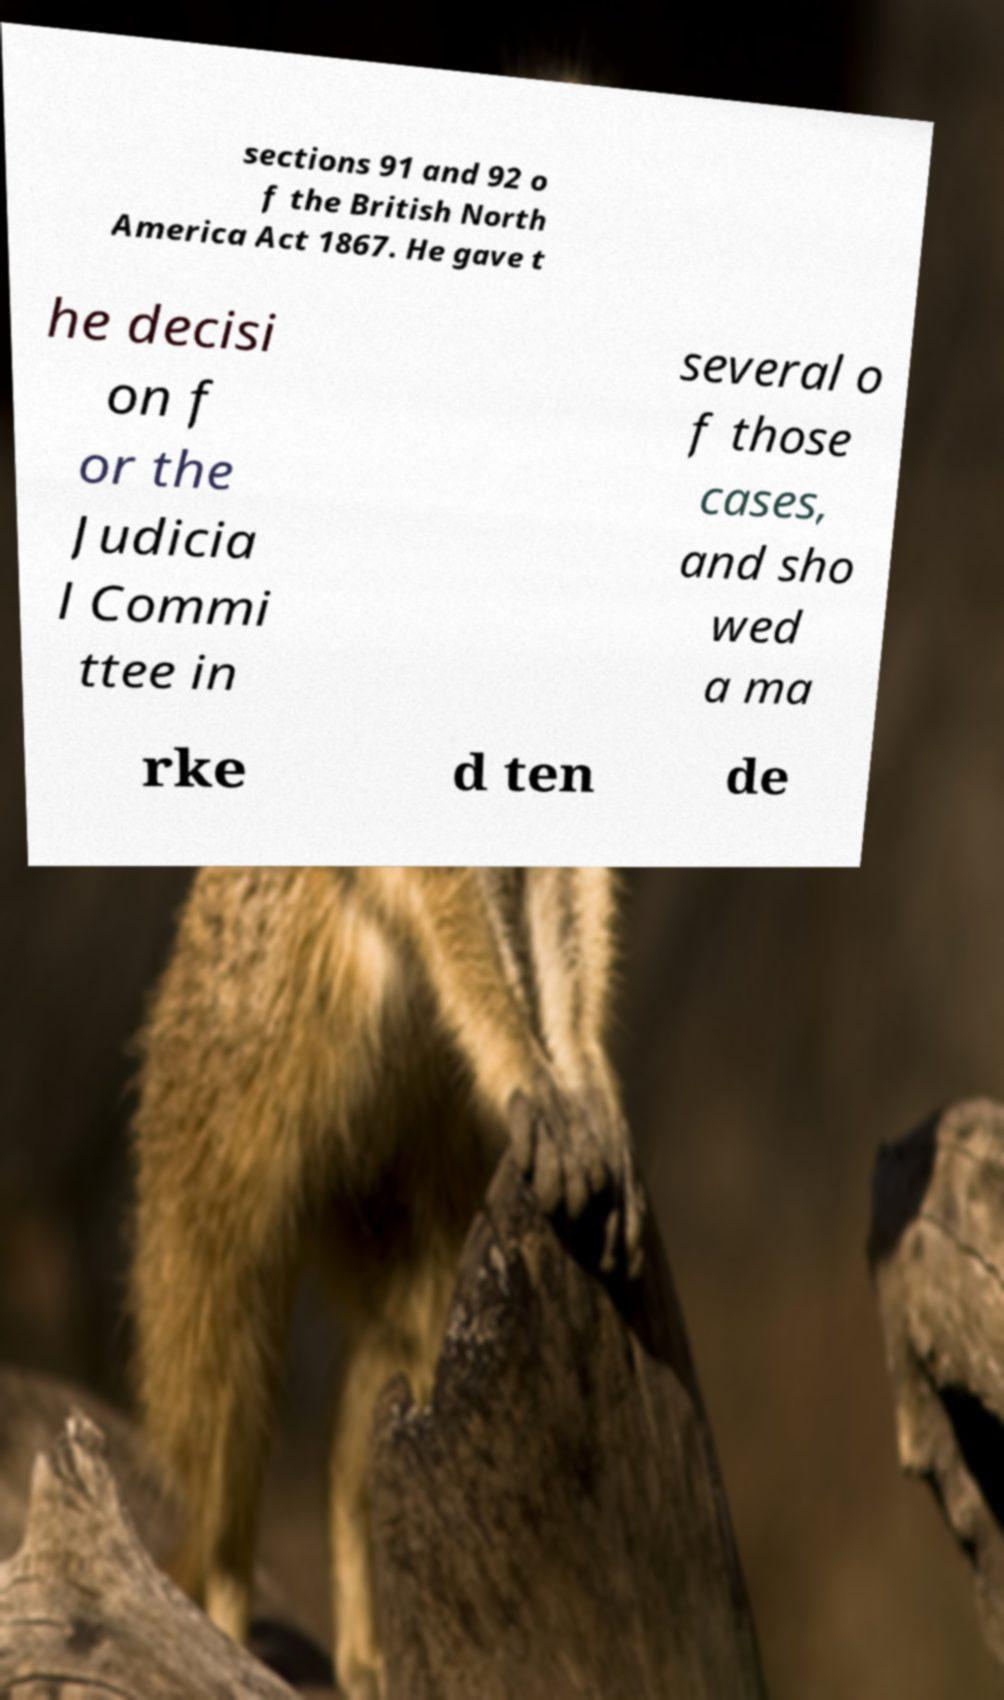Could you assist in decoding the text presented in this image and type it out clearly? sections 91 and 92 o f the British North America Act 1867. He gave t he decisi on f or the Judicia l Commi ttee in several o f those cases, and sho wed a ma rke d ten de 